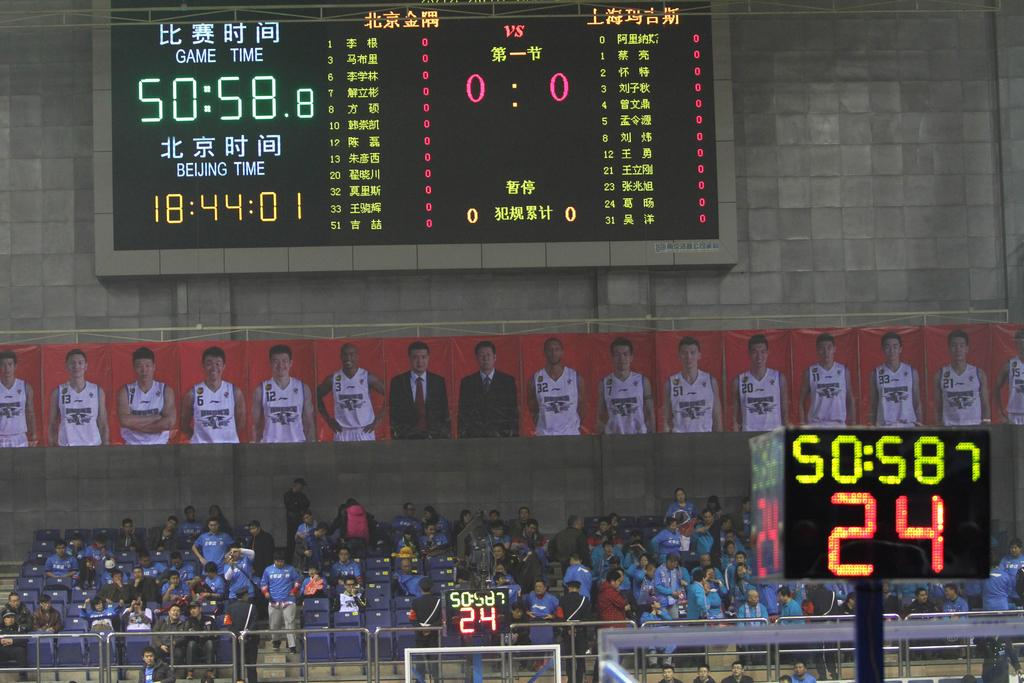<image>
Give a short and clear explanation of the subsequent image. A basketball game in China is underway and the clock says 50:58. 